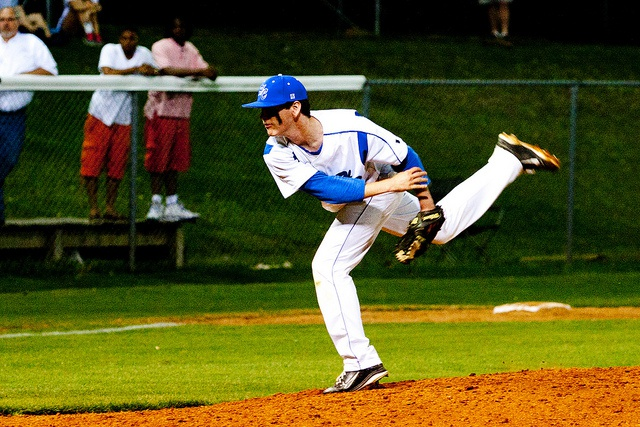Describe the objects in this image and their specific colors. I can see people in gray, white, black, blue, and darkgray tones, people in gray, black, maroon, lightpink, and darkgray tones, people in gray, black, maroon, and lavender tones, bench in gray, black, darkgreen, and olive tones, and people in gray, lavender, black, darkgray, and brown tones in this image. 